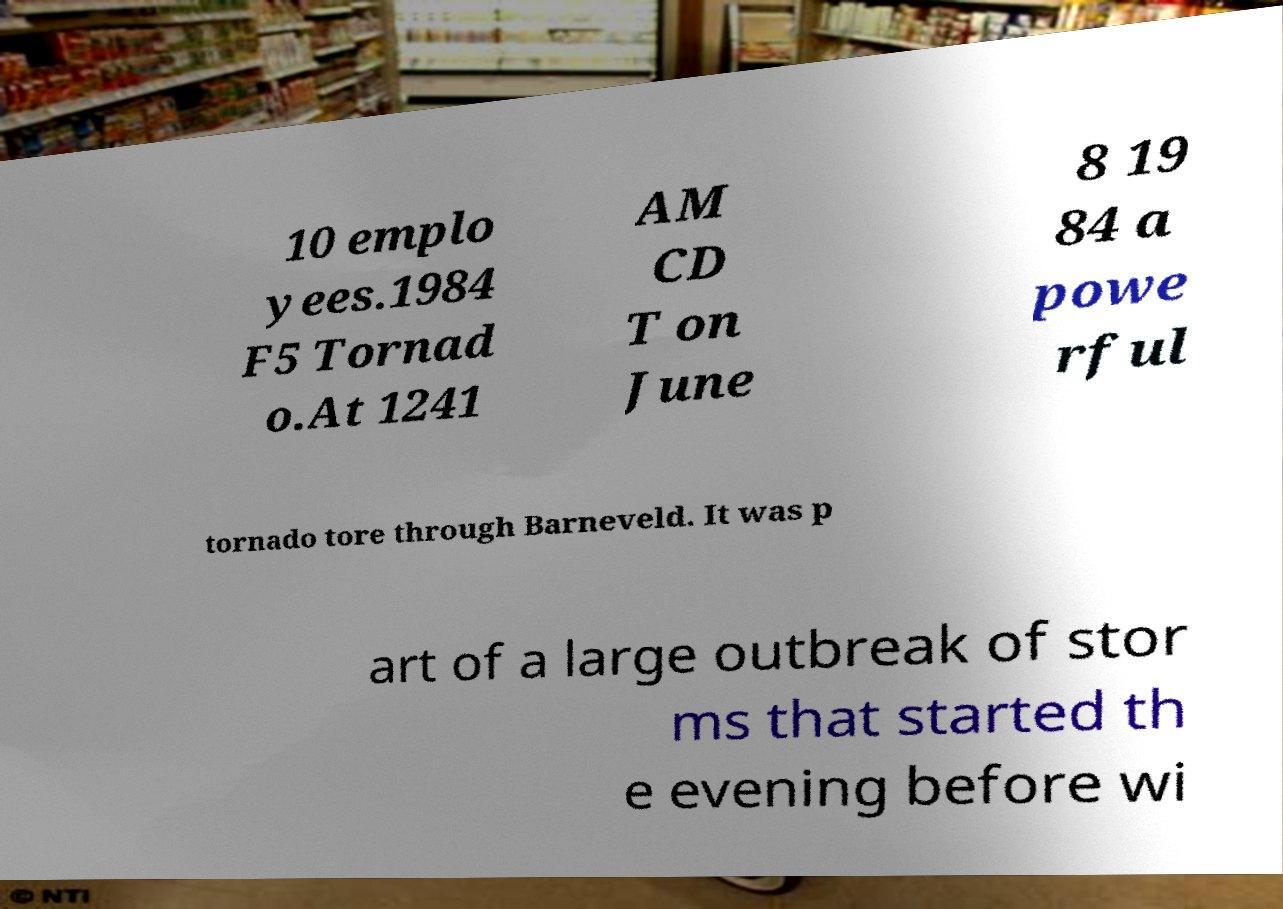Can you accurately transcribe the text from the provided image for me? 10 emplo yees.1984 F5 Tornad o.At 1241 AM CD T on June 8 19 84 a powe rful tornado tore through Barneveld. It was p art of a large outbreak of stor ms that started th e evening before wi 